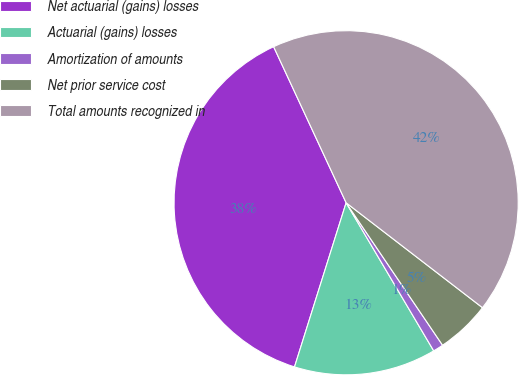Convert chart to OTSL. <chart><loc_0><loc_0><loc_500><loc_500><pie_chart><fcel>Net actuarial (gains) losses<fcel>Actuarial (gains) losses<fcel>Amortization of amounts<fcel>Net prior service cost<fcel>Total amounts recognized in<nl><fcel>38.23%<fcel>13.35%<fcel>0.97%<fcel>5.09%<fcel>42.36%<nl></chart> 